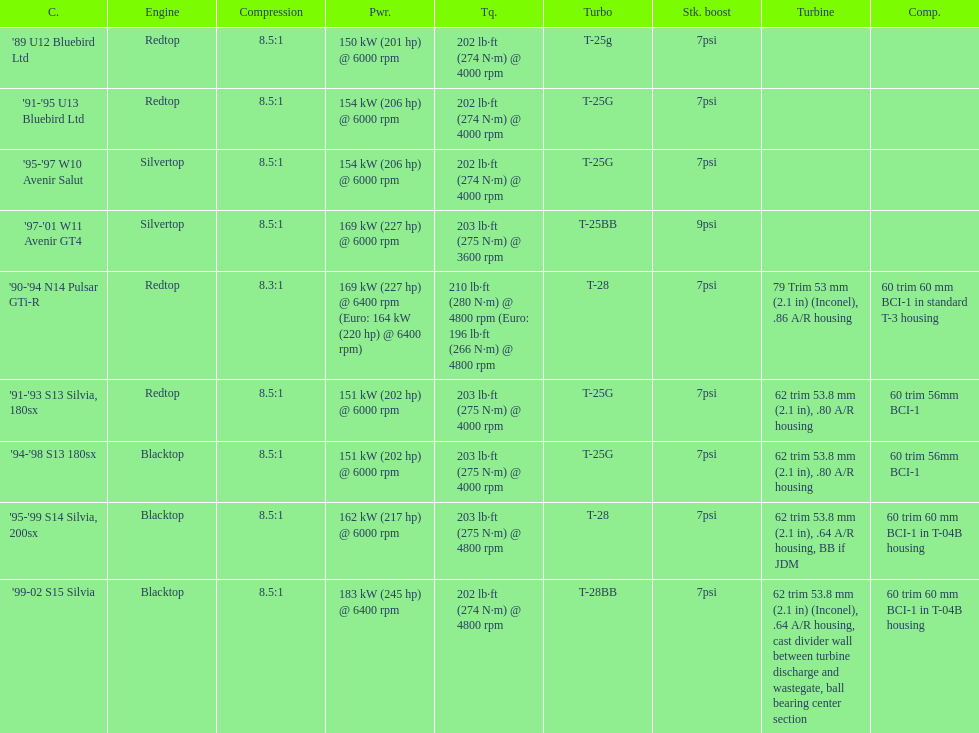Which engines were used after 1999? Silvertop, Blacktop. 